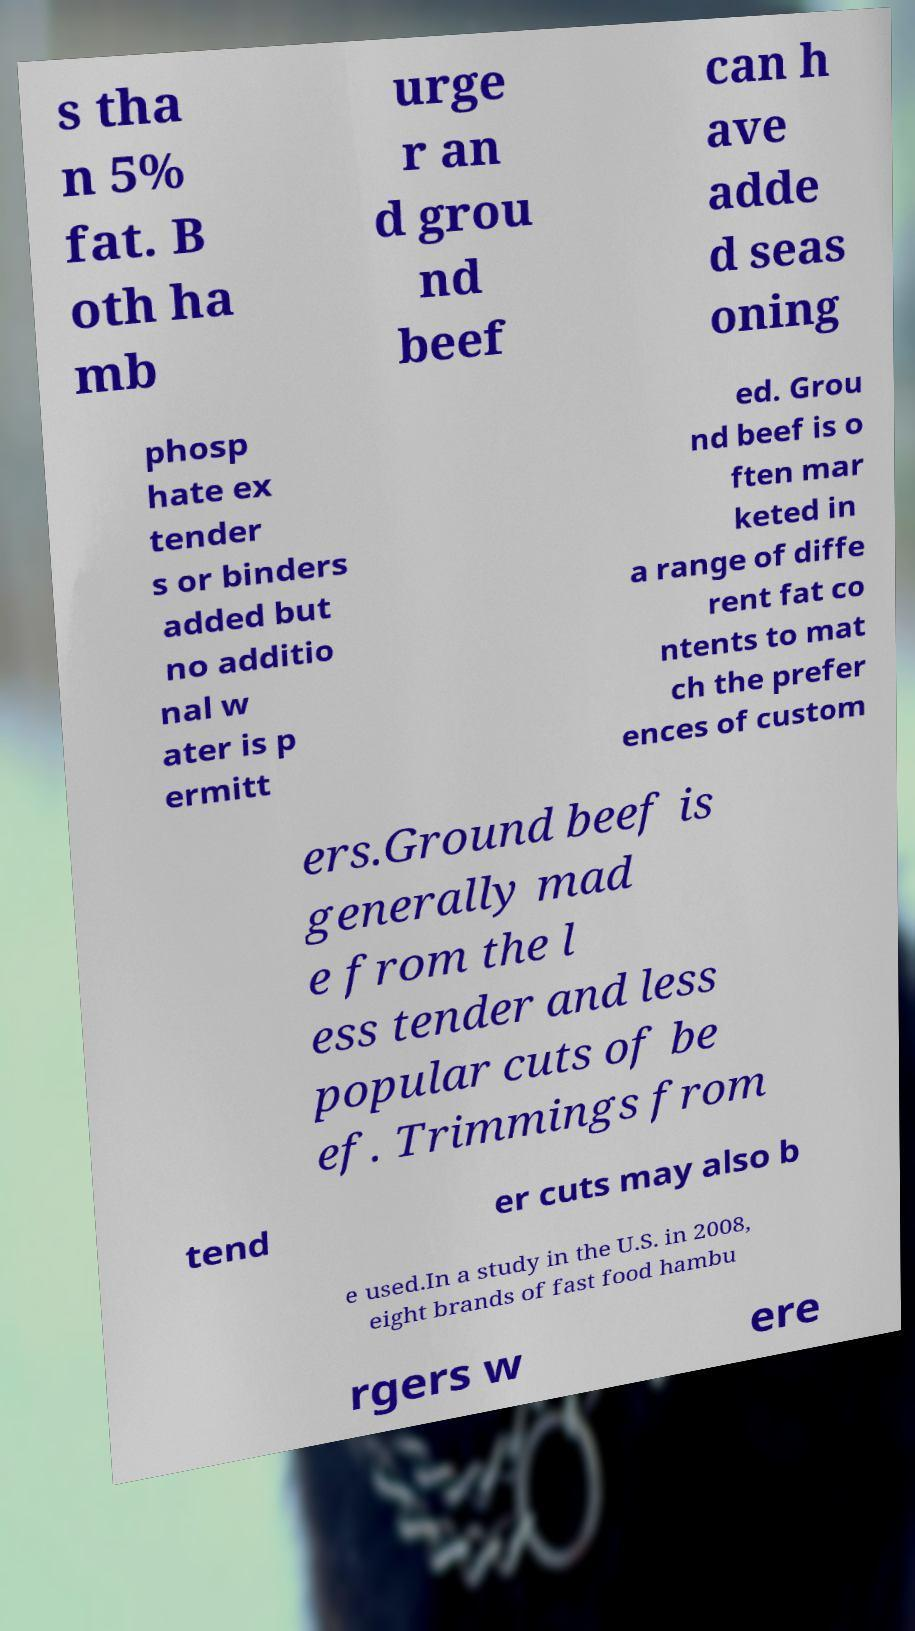Could you assist in decoding the text presented in this image and type it out clearly? s tha n 5% fat. B oth ha mb urge r an d grou nd beef can h ave adde d seas oning phosp hate ex tender s or binders added but no additio nal w ater is p ermitt ed. Grou nd beef is o ften mar keted in a range of diffe rent fat co ntents to mat ch the prefer ences of custom ers.Ground beef is generally mad e from the l ess tender and less popular cuts of be ef. Trimmings from tend er cuts may also b e used.In a study in the U.S. in 2008, eight brands of fast food hambu rgers w ere 